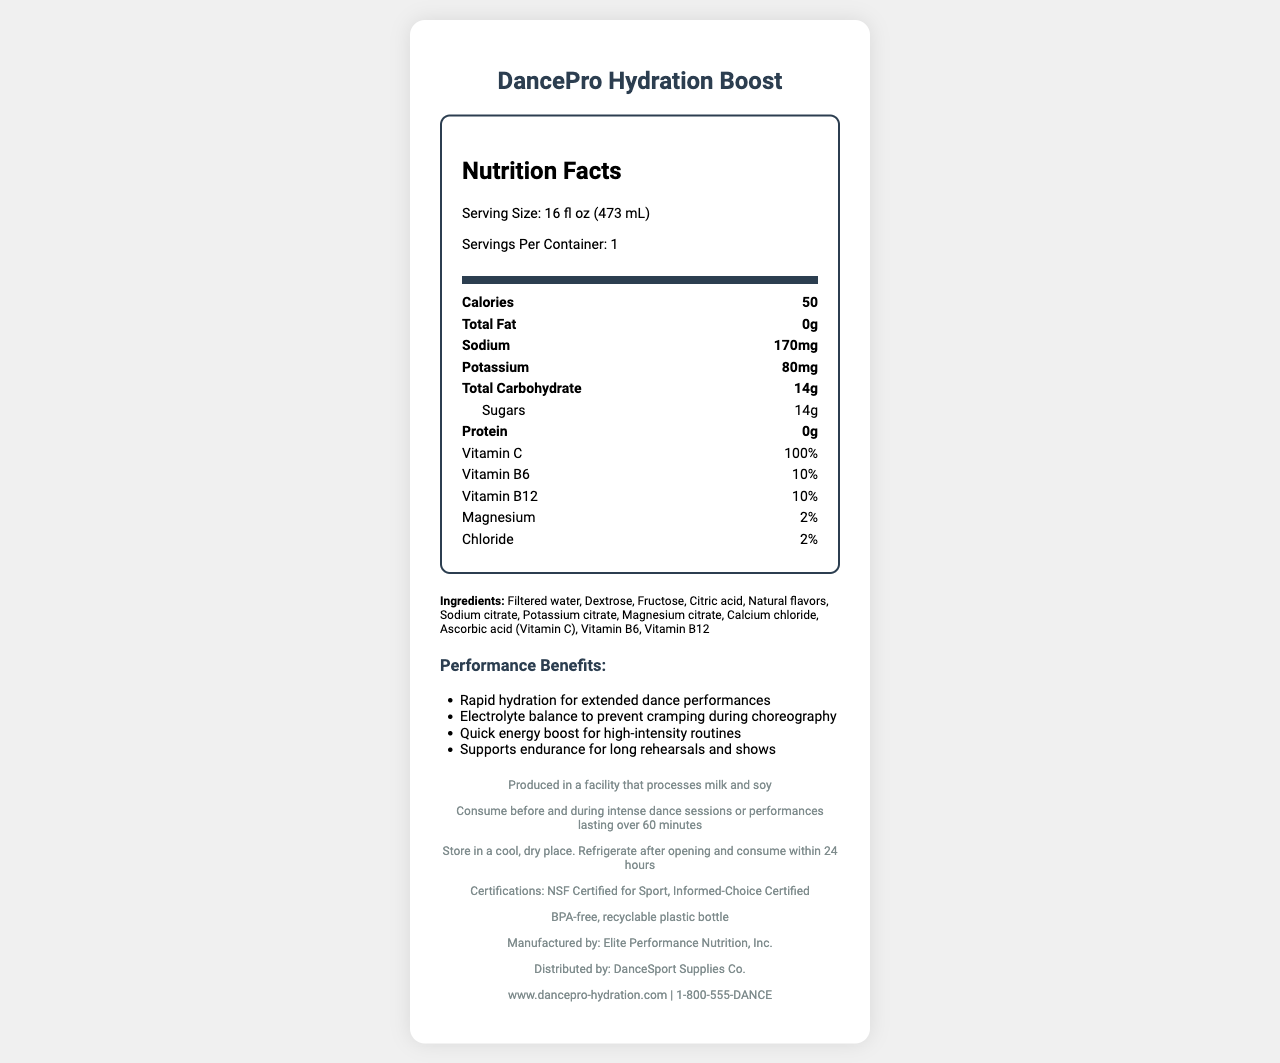what is the serving size of DancePro Hydration Boost? The serving size is stated directly in the nutrition facts section of the document.
Answer: 16 fl oz (473 mL) how many calories are there per serving? The calories per serving are listed under the nutrition facts.
Answer: 50 how much sodium is in one serving of DancePro Hydration Boost? The sodium content is listed in the nutrition facts.
Answer: 170 mg what vitamins are present in DancePro Hydration Boost? These vitamins are explicitly stated along with their percentages in the nutrition facts section.
Answer: Vitamin C, Vitamin B6, Vitamin B12 what is the main ingredient in DancePro Hydration Boost? The ingredient list starts with "Filtered water," indicating it’s the main ingredient.
Answer: Filtered water which company manufactures DancePro Hydration Boost? A. DanceSport Supplies Co. B. Elite Performance Nutrition, Inc. C. DancePro Inc. D. Sports Nutrition Ltd. The document states that the manufacturer is Elite Performance Nutrition, Inc.
Answer: B how many carbohydrates are there in DancePro Hydration Boost? A. 10g B. 14g C. 20g D. 2g The total carbohydrate content is listed as 14g in the document.
Answer: B does DancePro Hydration Boost contain any fat? The nutrition facts specify that there are 0g of total fat.
Answer: No is DancePro Hydration Boost certified for sport use? The document mentions that the product has NSF Certified for Sport and Informed-Choice Certified.
Answer: Yes can I store DancePro Hydration Boost at room temperature after opening? The storage instructions indicate that the product should be refrigerated after opening and consumed within 24 hours.
Answer: No describe the main idea of the document. The document covers various aspects including nutritional content, ingredients, recommended use, certifications, and storage instructions, focusing on how the drink supports hydration and performance for dancers.
Answer: The document provides detailed nutrition facts, ingredients, performance benefits, and other relevant information about DancePro Hydration Boost, an electrolyte-rich sports drink designed for hydration during intense dance performances. how many grams of sugar are in one serving? The amount of sugar per serving is indicated in the nutrition facts.
Answer: 14g does DancePro Hydration Boost contain any allergens? The allergen information states that it is produced in a facility that processes milk and soy.
Answer: Produced in a facility that processes milk and soy what are the ingredients in the drink? The document lists all the ingredients used in the drink.
Answer: Filtered water, Dextrose, Fructose, Citric acid, Natural flavors, Sodium citrate, Potassium citrate, Magnesium citrate, Calcium chloride, Ascorbic acid (Vitamin C), Vitamin B6, Vitamin B12 what are the performance benefits of DancePro Hydration Boost? The document outlines that the drink offers rapid hydration, maintains electrolyte balance, provides a quick energy boost, and supports endurance.
Answer: Rapid hydration, Electrolyte balance, Quick energy boost, Supports endurance how much potassium is in one serving? The potassium content is listed under the nutrition facts.
Answer: 80 mg when should DancePro Hydration Boost be consumed? The recommended use section specifies this.
Answer: Before and during intense dance sessions or performances lasting over 60 minutes what type of bottle is DancePro Hydration Boost packaged in? The packaging information specifies the type of bottle.
Answer: BPA-free, recyclable plastic bottle who distributes DancePro Hydration Boost? The document mentions that the distributor is DanceSport Supplies Co.
Answer: DanceSport Supplies Co. what is the primary purpose of DancePro Hydration Boost? The performance benefits and recommended use sections highlight how the drink is designed to support dancers during performances.
Answer: The primary purpose is to provide rapid hydration, maintain electrolyte balance, give a quick energy boost, and support endurance during intense dance performances. does DancePro Hydration Boost contain caffeine? The document does not mention the presence of caffeine; therefore, it cannot be determined from the provided information.
Answer: Cannot be determined 